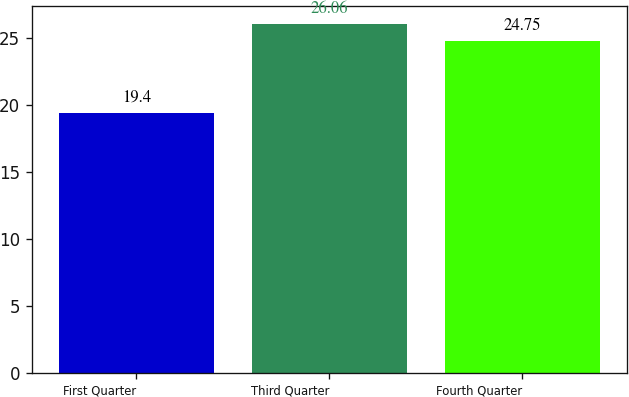Convert chart. <chart><loc_0><loc_0><loc_500><loc_500><bar_chart><fcel>First Quarter<fcel>Third Quarter<fcel>Fourth Quarter<nl><fcel>19.4<fcel>26.06<fcel>24.75<nl></chart> 